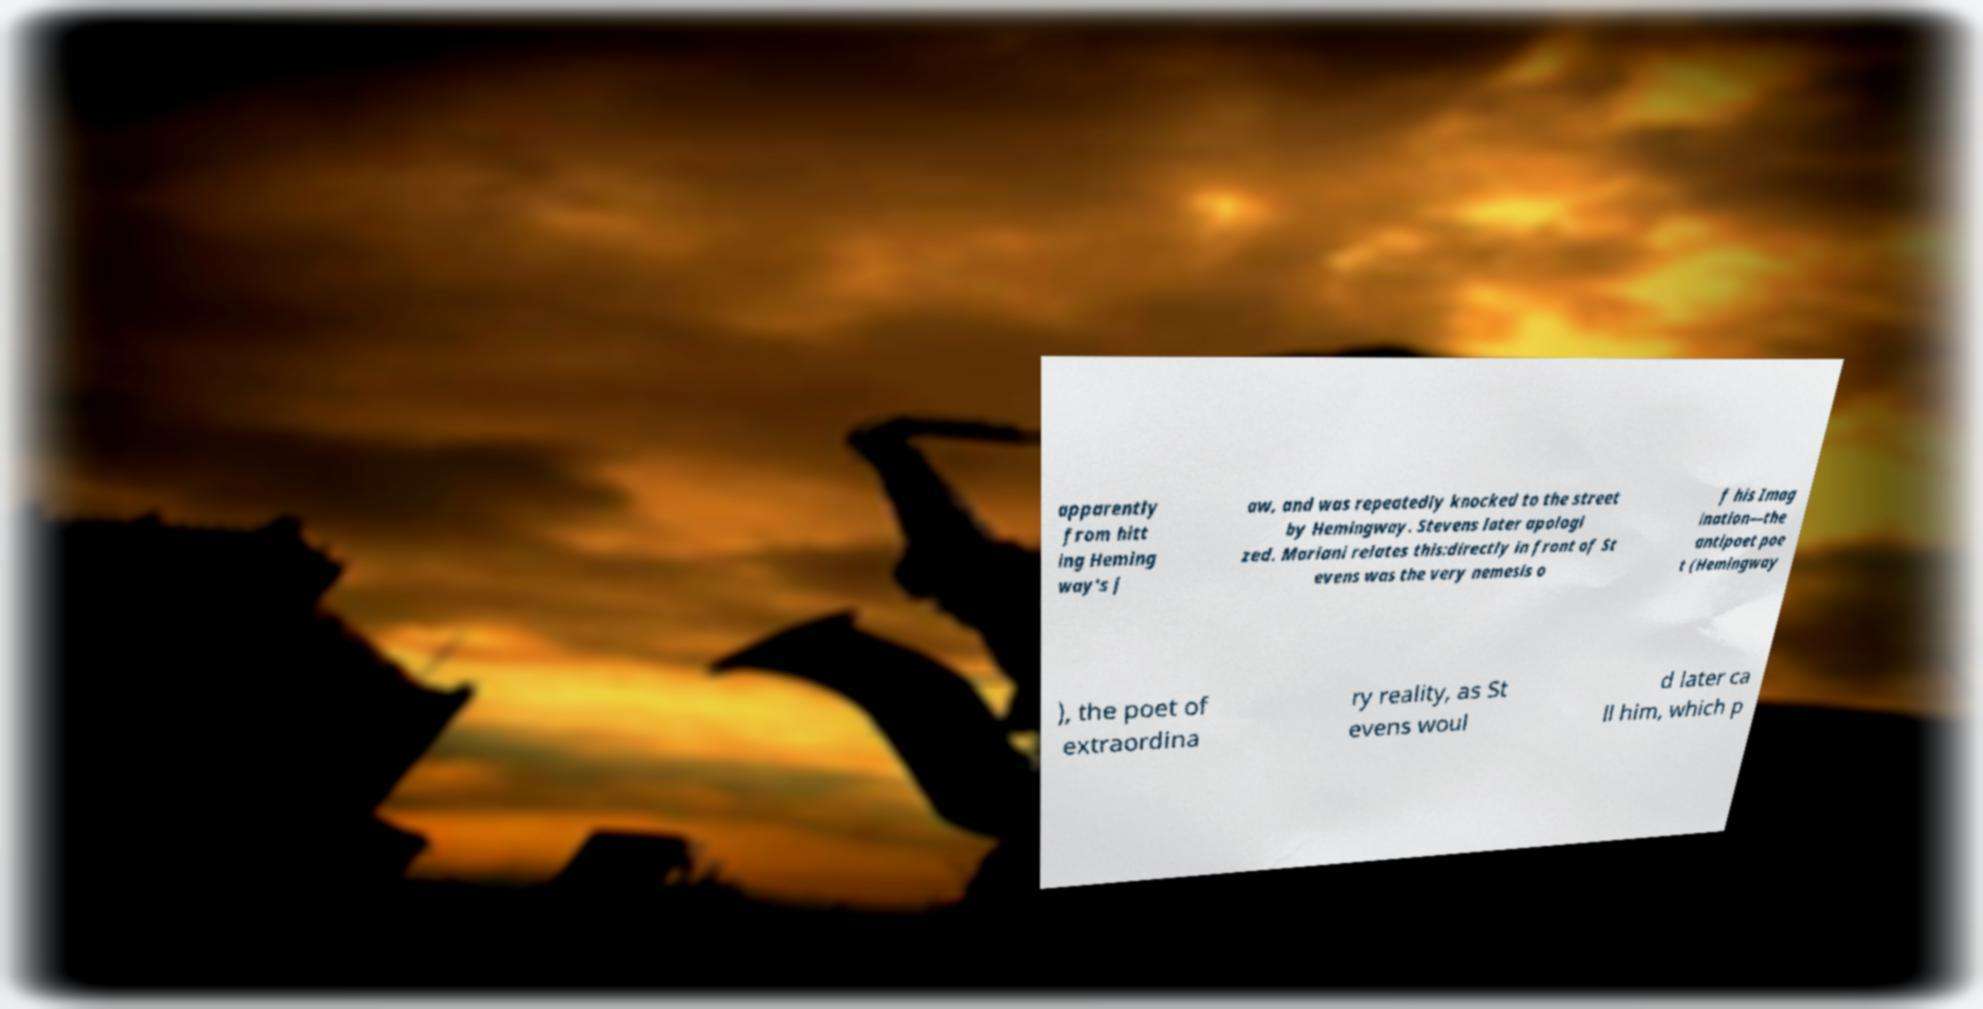Could you assist in decoding the text presented in this image and type it out clearly? apparently from hitt ing Heming way's j aw, and was repeatedly knocked to the street by Hemingway. Stevens later apologi zed. Mariani relates this:directly in front of St evens was the very nemesis o f his Imag ination—the antipoet poe t (Hemingway ), the poet of extraordina ry reality, as St evens woul d later ca ll him, which p 